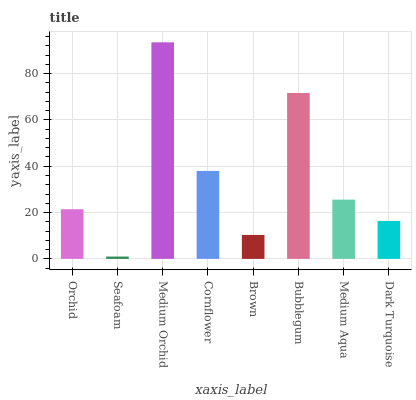Is Medium Orchid the minimum?
Answer yes or no. No. Is Seafoam the maximum?
Answer yes or no. No. Is Medium Orchid greater than Seafoam?
Answer yes or no. Yes. Is Seafoam less than Medium Orchid?
Answer yes or no. Yes. Is Seafoam greater than Medium Orchid?
Answer yes or no. No. Is Medium Orchid less than Seafoam?
Answer yes or no. No. Is Medium Aqua the high median?
Answer yes or no. Yes. Is Orchid the low median?
Answer yes or no. Yes. Is Bubblegum the high median?
Answer yes or no. No. Is Medium Orchid the low median?
Answer yes or no. No. 